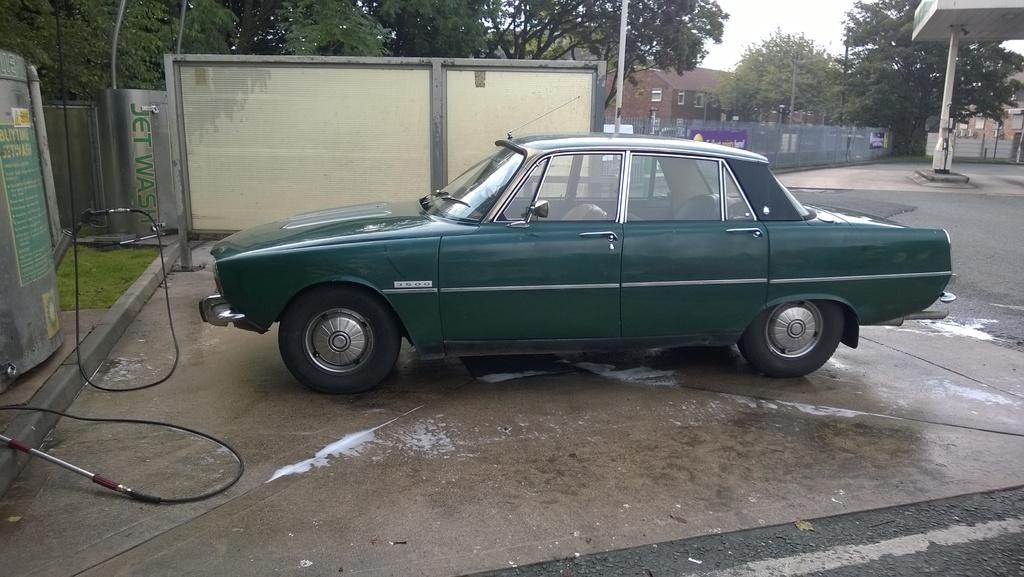Describe this image in one or two sentences. It is a car in green color, on the left side there are trees. In the middle there are houses in this image. 